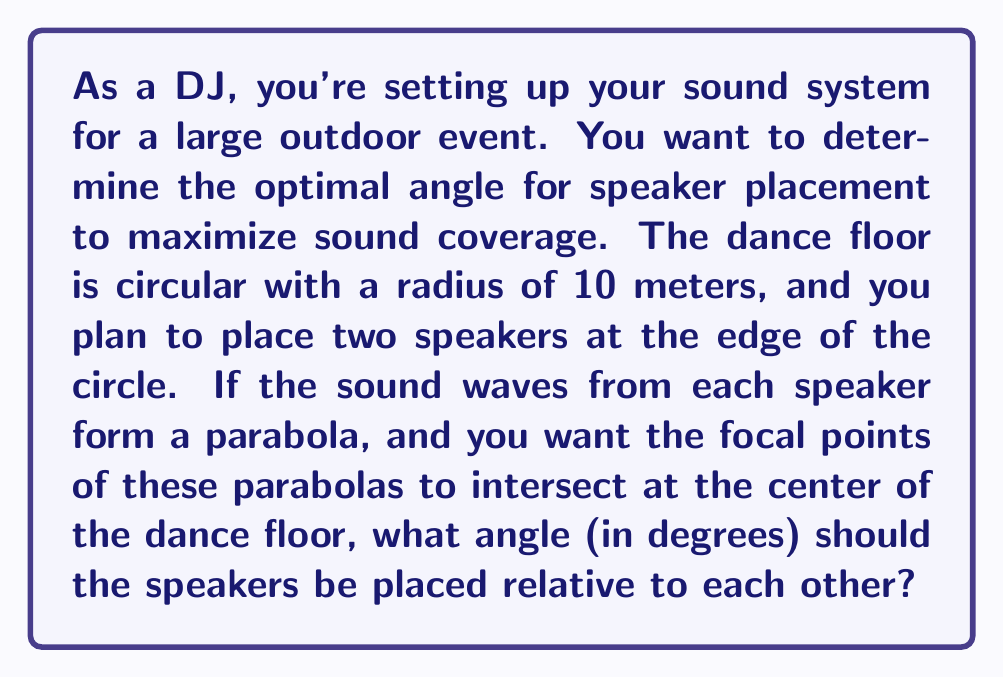Help me with this question. Let's approach this step-by-step using conic sections:

1) In this scenario, we're dealing with two parabolas whose focal points meet at the center of the circle (dance floor).

2) For a parabola, the distance from any point on the parabola to the focus is equal to the distance from that point to the directrix.

3) In our case, the speakers are at the vertex of each parabola, and the center of the circle is the focus.

4) Let's consider one of the parabolas. We can represent it in polar form as:

   $$r = \frac{p}{1 - \cos\theta}$$

   where $r$ is the radius, $p$ is the focal parameter, and $\theta$ is the angle from the axis of symmetry.

5) We know that when $\theta = 0$, $r$ should equal the radius of the circle (10 meters). So:

   $$10 = \frac{p}{1 - 1} = \infty$$

   This means the denominator must approach 0, not equal 0.

6) Let's say the angle we're looking for is $\alpha$. Then:

   $$10 = \frac{p}{1 - \cos(\alpha/2)}$$

7) Solving for $p$:

   $$p = 10(1 - \cos(\alpha/2))$$

8) Now, we want the distance from the speaker to the center (10) to equal the distance from the speaker to the directrix. This gives us:

   $$10 = \frac{p}{2} = \frac{10(1 - \cos(\alpha/2))}{2}$$

9) Simplifying:

   $$2 = 1 - \cos(\alpha/2)$$
   $$\cos(\alpha/2) = -1$$

10) Solving for $\alpha$:

    $$\alpha/2 = \arccos(-1) = \pi$$
    $$\alpha = 2\pi$$

11) Converting to degrees:

    $$\alpha = 2\pi * \frac{180}{\pi} = 360°$$

Therefore, the speakers should be placed 360° apart, which means they should be at the same point. In practice, this isn't feasible, so we would place them as close together as physically possible while still allowing for stereo separation.
Answer: 360° 